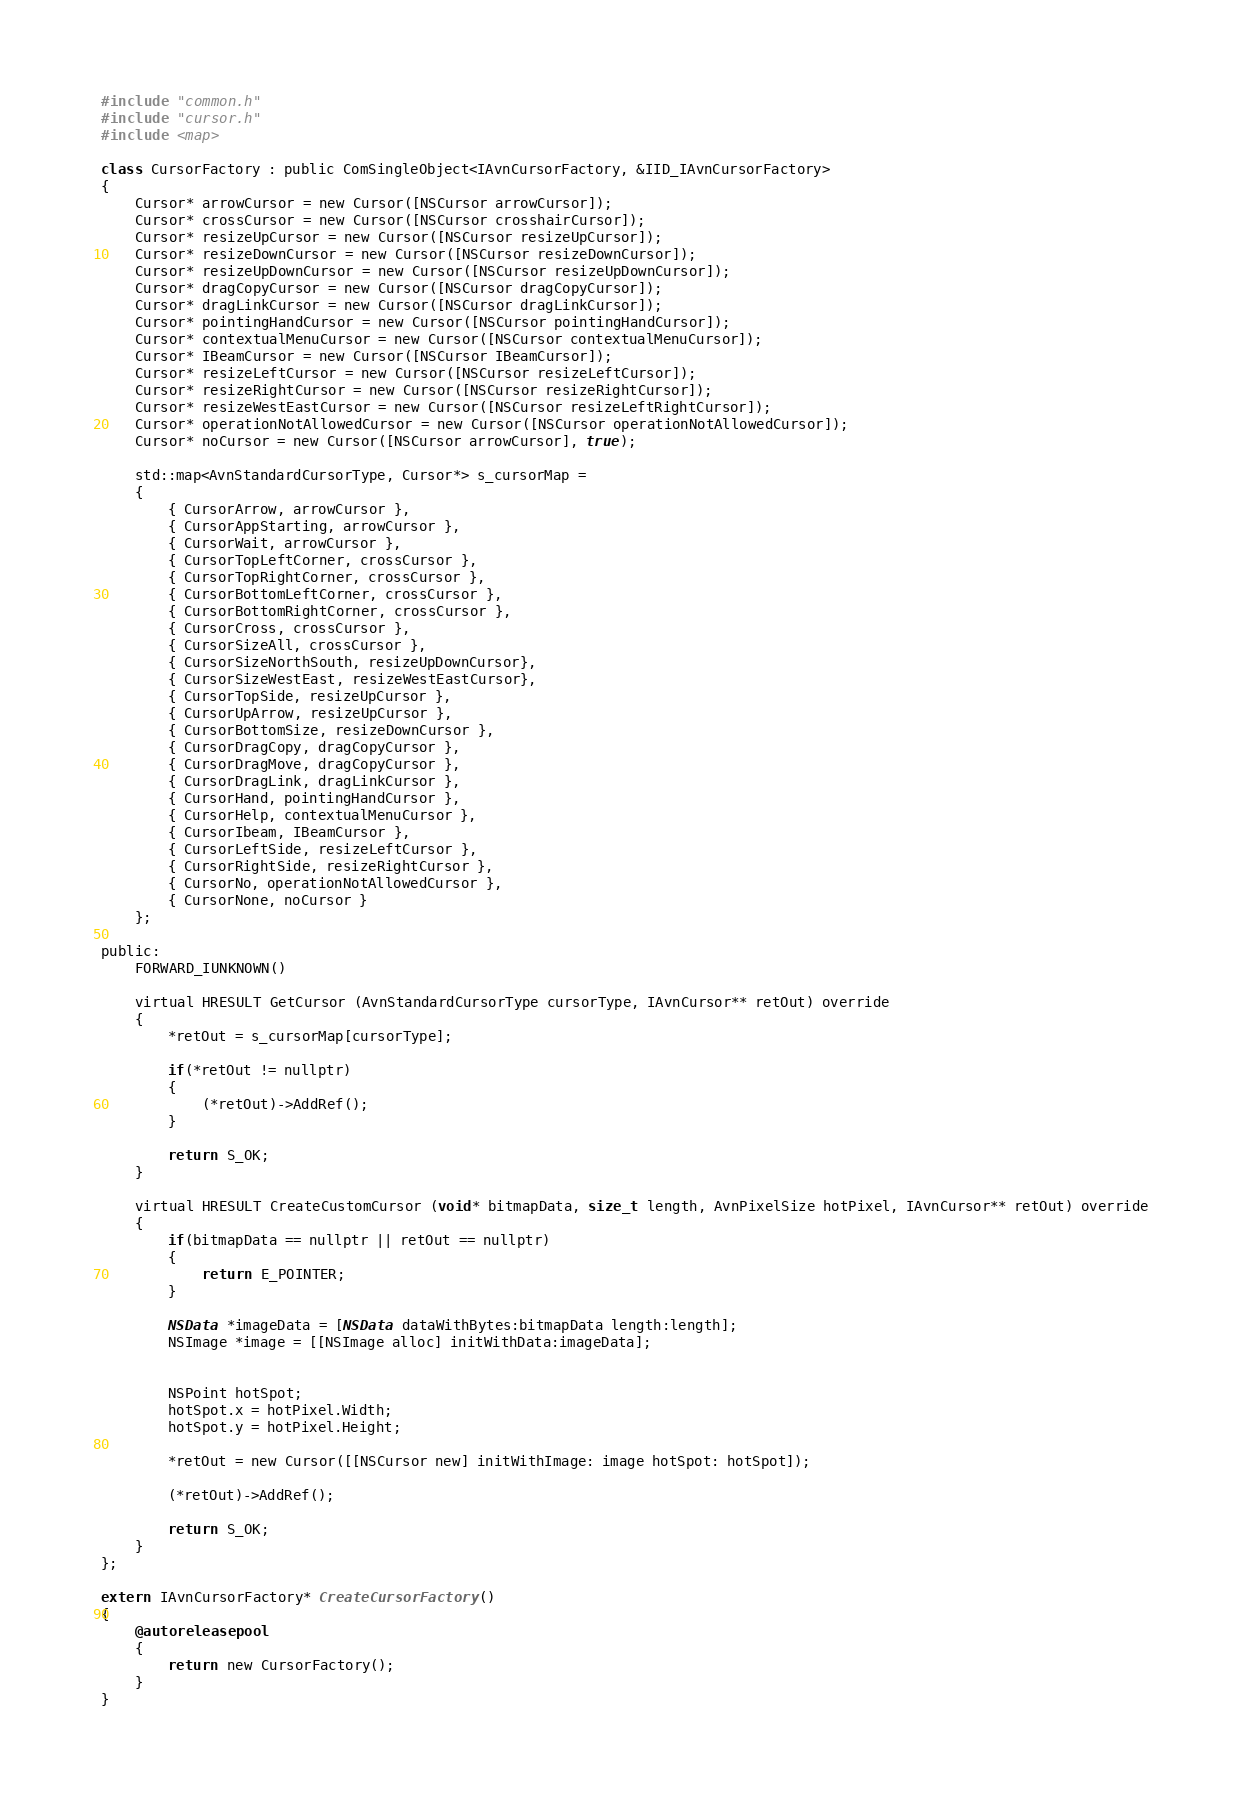Convert code to text. <code><loc_0><loc_0><loc_500><loc_500><_ObjectiveC_>#include "common.h"
#include "cursor.h"
#include <map>

class CursorFactory : public ComSingleObject<IAvnCursorFactory, &IID_IAvnCursorFactory>
{
    Cursor* arrowCursor = new Cursor([NSCursor arrowCursor]);
    Cursor* crossCursor = new Cursor([NSCursor crosshairCursor]);
    Cursor* resizeUpCursor = new Cursor([NSCursor resizeUpCursor]);
    Cursor* resizeDownCursor = new Cursor([NSCursor resizeDownCursor]);
    Cursor* resizeUpDownCursor = new Cursor([NSCursor resizeUpDownCursor]);
    Cursor* dragCopyCursor = new Cursor([NSCursor dragCopyCursor]);
    Cursor* dragLinkCursor = new Cursor([NSCursor dragLinkCursor]);
    Cursor* pointingHandCursor = new Cursor([NSCursor pointingHandCursor]);
    Cursor* contextualMenuCursor = new Cursor([NSCursor contextualMenuCursor]);
    Cursor* IBeamCursor = new Cursor([NSCursor IBeamCursor]);
    Cursor* resizeLeftCursor = new Cursor([NSCursor resizeLeftCursor]);
    Cursor* resizeRightCursor = new Cursor([NSCursor resizeRightCursor]);
    Cursor* resizeWestEastCursor = new Cursor([NSCursor resizeLeftRightCursor]);
    Cursor* operationNotAllowedCursor = new Cursor([NSCursor operationNotAllowedCursor]);
    Cursor* noCursor = new Cursor([NSCursor arrowCursor], true);

    std::map<AvnStandardCursorType, Cursor*> s_cursorMap =
    {
        { CursorArrow, arrowCursor },
        { CursorAppStarting, arrowCursor },
        { CursorWait, arrowCursor },
        { CursorTopLeftCorner, crossCursor },
        { CursorTopRightCorner, crossCursor },
        { CursorBottomLeftCorner, crossCursor },
        { CursorBottomRightCorner, crossCursor },
        { CursorCross, crossCursor },
        { CursorSizeAll, crossCursor },
        { CursorSizeNorthSouth, resizeUpDownCursor},
        { CursorSizeWestEast, resizeWestEastCursor},
        { CursorTopSide, resizeUpCursor },
        { CursorUpArrow, resizeUpCursor },
        { CursorBottomSize, resizeDownCursor },
        { CursorDragCopy, dragCopyCursor },
        { CursorDragMove, dragCopyCursor },
        { CursorDragLink, dragLinkCursor },
        { CursorHand, pointingHandCursor },
        { CursorHelp, contextualMenuCursor },
        { CursorIbeam, IBeamCursor },
        { CursorLeftSide, resizeLeftCursor },
        { CursorRightSide, resizeRightCursor },
        { CursorNo, operationNotAllowedCursor },
        { CursorNone, noCursor }
    };

public:
    FORWARD_IUNKNOWN()
    
    virtual HRESULT GetCursor (AvnStandardCursorType cursorType, IAvnCursor** retOut) override
    {
        *retOut = s_cursorMap[cursorType];
        
        if(*retOut != nullptr)
        {
            (*retOut)->AddRef();
        }
            
        return S_OK;
    }
    
    virtual HRESULT CreateCustomCursor (void* bitmapData, size_t length, AvnPixelSize hotPixel, IAvnCursor** retOut) override
    {
        if(bitmapData == nullptr || retOut == nullptr)
        {
            return E_POINTER;
        }
        
        NSData *imageData = [NSData dataWithBytes:bitmapData length:length];
        NSImage *image = [[NSImage alloc] initWithData:imageData];
        
        
        NSPoint hotSpot;
        hotSpot.x = hotPixel.Width;
        hotSpot.y = hotPixel.Height;
        
        *retOut = new Cursor([[NSCursor new] initWithImage: image hotSpot: hotSpot]);
        
        (*retOut)->AddRef();
        
        return S_OK;
    }
};

extern IAvnCursorFactory* CreateCursorFactory()
{
    @autoreleasepool
    {
        return new CursorFactory();
    }
}
</code> 